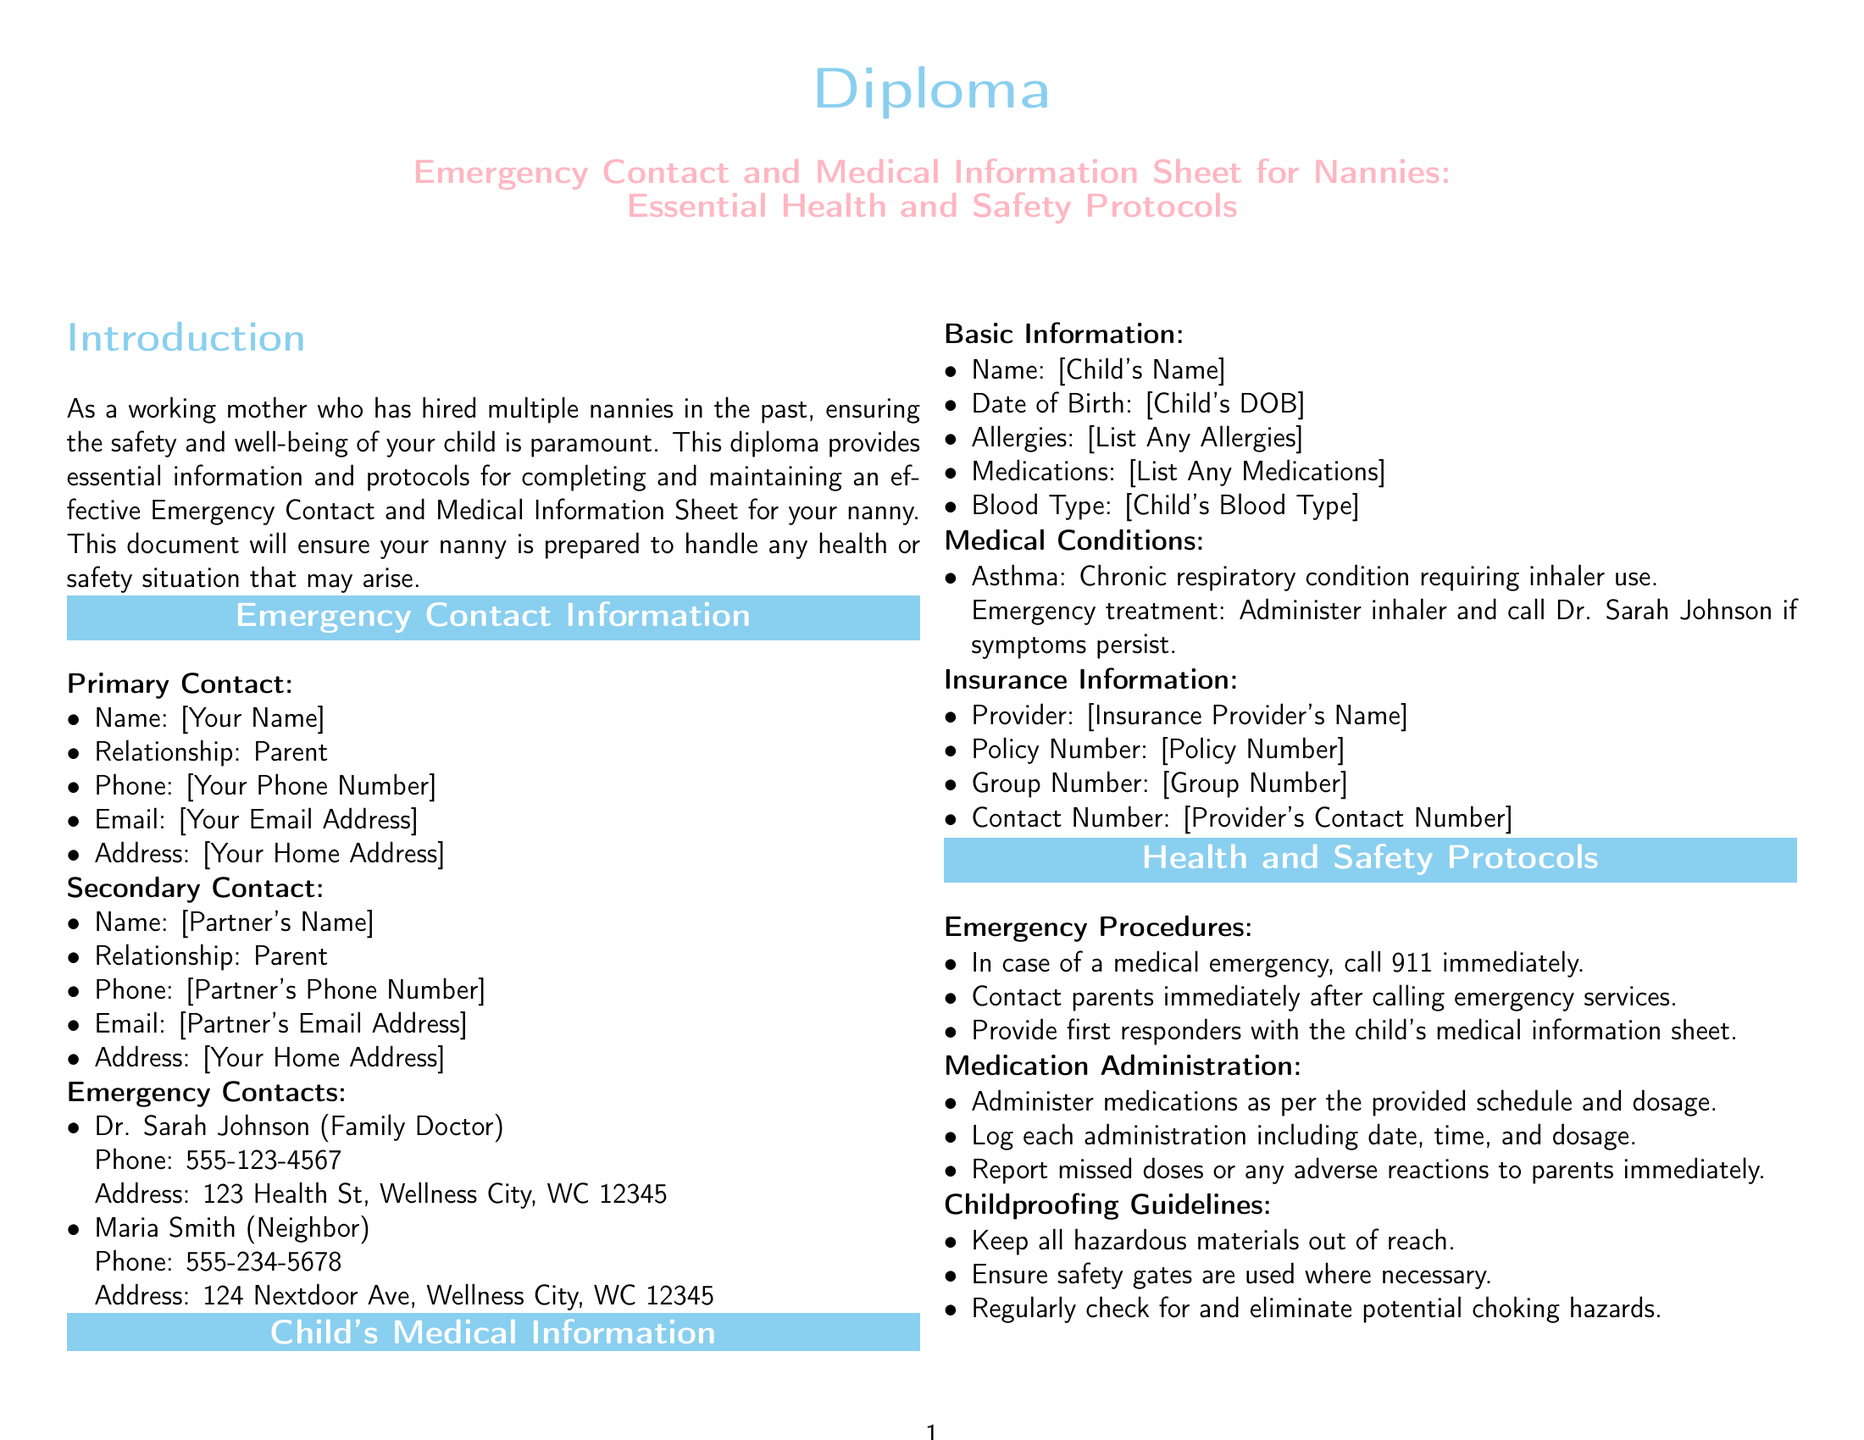What is the primary contact's name? The primary contact's name is listed under Emergency Contact Information.
Answer: [Your Name] What is the phone number for Dr. Sarah Johnson? The phone number for Dr. Sarah Johnson is provided under Emergency Contacts.
Answer: 555-123-4567 What is stated as the child's medical condition? The medical conditions section outlines the child's asthma condition.
Answer: Asthma What should be done in case of a medical emergency? The emergency procedures detail the steps to take in a medical emergency.
Answer: Call 911 immediately What color is used for the section titles? The document specifies a unique color for section titles.
Answer: Baby blue What is one of the childproofing guidelines mentioned? The Childproofing Guidelines section lists safety measures.
Answer: Keep all hazardous materials out of reach What must be logged when administering medication? The Medication Administration section outlines what should be documented.
Answer: Date, time, and dosage What is the purpose of this diploma? The introduction provides the main intent of the diploma for nannies.
Answer: Ensure child safety What medical information should be provided to first responders? Emergency Procedures outlines what to give to first responders.
Answer: Child's medical information sheet 